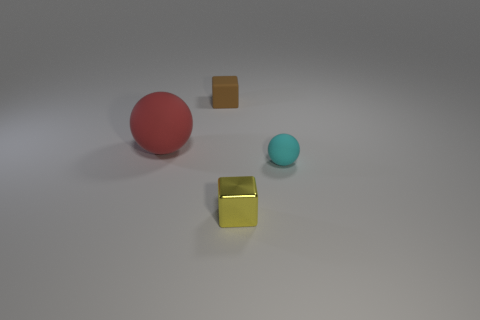What number of matte things are yellow spheres or red spheres? In the image, we can observe two spheres. One sphere is red, and the other sphere appears blue, not yellow. There are also two cubes; one appears yellow with a metallic or shiny surface, not matte, and another cube that is brown. Therefore, there is only one matte sphere that is red. The presence of a yellow sphere cannot be confirmed as there are no yellow spheres visible in the image. 